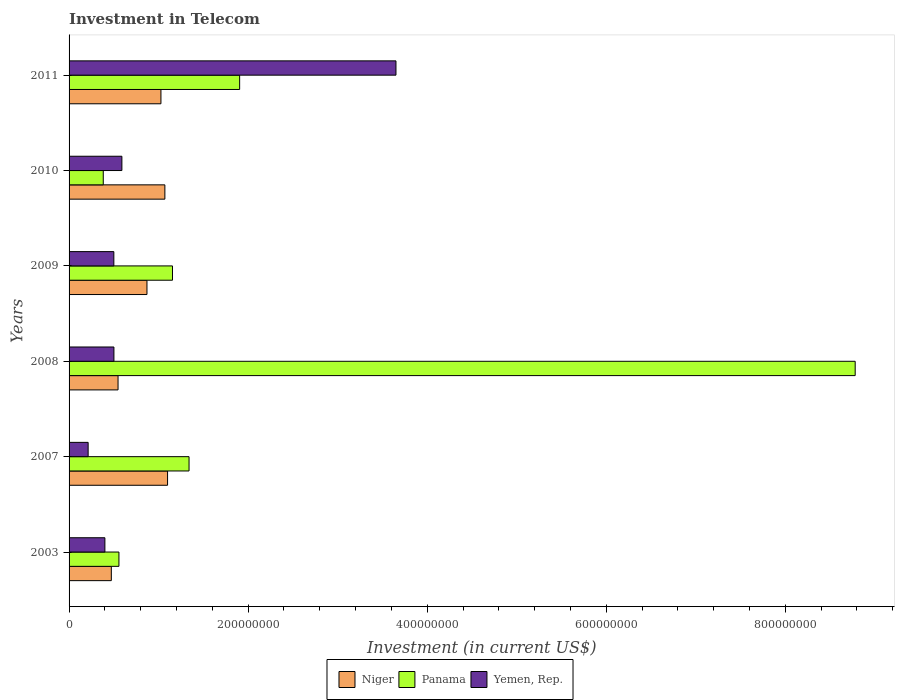How many groups of bars are there?
Provide a short and direct response. 6. How many bars are there on the 1st tick from the top?
Keep it short and to the point. 3. What is the label of the 6th group of bars from the top?
Keep it short and to the point. 2003. What is the amount invested in telecom in Panama in 2003?
Give a very brief answer. 5.57e+07. Across all years, what is the maximum amount invested in telecom in Yemen, Rep.?
Provide a succinct answer. 3.65e+08. Across all years, what is the minimum amount invested in telecom in Panama?
Give a very brief answer. 3.82e+07. In which year was the amount invested in telecom in Yemen, Rep. maximum?
Your answer should be very brief. 2011. In which year was the amount invested in telecom in Yemen, Rep. minimum?
Provide a short and direct response. 2007. What is the total amount invested in telecom in Yemen, Rep. in the graph?
Your response must be concise. 5.86e+08. What is the difference between the amount invested in telecom in Yemen, Rep. in 2009 and that in 2010?
Keep it short and to the point. -9.00e+06. What is the difference between the amount invested in telecom in Panama in 2010 and the amount invested in telecom in Niger in 2007?
Ensure brevity in your answer.  -7.18e+07. What is the average amount invested in telecom in Yemen, Rep. per year?
Ensure brevity in your answer.  9.76e+07. In the year 2003, what is the difference between the amount invested in telecom in Niger and amount invested in telecom in Panama?
Provide a succinct answer. -8.50e+06. Is the amount invested in telecom in Panama in 2007 less than that in 2010?
Offer a very short reply. No. What is the difference between the highest and the second highest amount invested in telecom in Niger?
Offer a terse response. 3.00e+06. What is the difference between the highest and the lowest amount invested in telecom in Niger?
Offer a terse response. 6.28e+07. In how many years, is the amount invested in telecom in Yemen, Rep. greater than the average amount invested in telecom in Yemen, Rep. taken over all years?
Offer a very short reply. 1. Is the sum of the amount invested in telecom in Niger in 2007 and 2010 greater than the maximum amount invested in telecom in Panama across all years?
Offer a very short reply. No. What does the 3rd bar from the top in 2007 represents?
Keep it short and to the point. Niger. What does the 1st bar from the bottom in 2007 represents?
Make the answer very short. Niger. Are all the bars in the graph horizontal?
Provide a succinct answer. Yes. How many years are there in the graph?
Provide a succinct answer. 6. What is the difference between two consecutive major ticks on the X-axis?
Provide a succinct answer. 2.00e+08. Are the values on the major ticks of X-axis written in scientific E-notation?
Provide a short and direct response. No. Does the graph contain grids?
Provide a succinct answer. No. How are the legend labels stacked?
Offer a terse response. Horizontal. What is the title of the graph?
Offer a very short reply. Investment in Telecom. Does "Libya" appear as one of the legend labels in the graph?
Keep it short and to the point. No. What is the label or title of the X-axis?
Your response must be concise. Investment (in current US$). What is the Investment (in current US$) of Niger in 2003?
Your answer should be very brief. 4.72e+07. What is the Investment (in current US$) of Panama in 2003?
Your answer should be compact. 5.57e+07. What is the Investment (in current US$) of Yemen, Rep. in 2003?
Keep it short and to the point. 4.00e+07. What is the Investment (in current US$) of Niger in 2007?
Your answer should be very brief. 1.10e+08. What is the Investment (in current US$) of Panama in 2007?
Ensure brevity in your answer.  1.34e+08. What is the Investment (in current US$) in Yemen, Rep. in 2007?
Your answer should be compact. 2.13e+07. What is the Investment (in current US$) in Niger in 2008?
Your answer should be very brief. 5.47e+07. What is the Investment (in current US$) of Panama in 2008?
Give a very brief answer. 8.78e+08. What is the Investment (in current US$) of Yemen, Rep. in 2008?
Your response must be concise. 5.01e+07. What is the Investment (in current US$) in Niger in 2009?
Make the answer very short. 8.70e+07. What is the Investment (in current US$) in Panama in 2009?
Your answer should be compact. 1.16e+08. What is the Investment (in current US$) of Yemen, Rep. in 2009?
Give a very brief answer. 5.00e+07. What is the Investment (in current US$) in Niger in 2010?
Ensure brevity in your answer.  1.07e+08. What is the Investment (in current US$) of Panama in 2010?
Offer a terse response. 3.82e+07. What is the Investment (in current US$) of Yemen, Rep. in 2010?
Your response must be concise. 5.90e+07. What is the Investment (in current US$) of Niger in 2011?
Ensure brevity in your answer.  1.03e+08. What is the Investment (in current US$) in Panama in 2011?
Provide a short and direct response. 1.90e+08. What is the Investment (in current US$) in Yemen, Rep. in 2011?
Keep it short and to the point. 3.65e+08. Across all years, what is the maximum Investment (in current US$) of Niger?
Make the answer very short. 1.10e+08. Across all years, what is the maximum Investment (in current US$) of Panama?
Provide a succinct answer. 8.78e+08. Across all years, what is the maximum Investment (in current US$) of Yemen, Rep.?
Provide a succinct answer. 3.65e+08. Across all years, what is the minimum Investment (in current US$) of Niger?
Keep it short and to the point. 4.72e+07. Across all years, what is the minimum Investment (in current US$) of Panama?
Your response must be concise. 3.82e+07. Across all years, what is the minimum Investment (in current US$) in Yemen, Rep.?
Offer a very short reply. 2.13e+07. What is the total Investment (in current US$) in Niger in the graph?
Make the answer very short. 5.08e+08. What is the total Investment (in current US$) of Panama in the graph?
Give a very brief answer. 1.41e+09. What is the total Investment (in current US$) in Yemen, Rep. in the graph?
Your answer should be very brief. 5.86e+08. What is the difference between the Investment (in current US$) in Niger in 2003 and that in 2007?
Keep it short and to the point. -6.28e+07. What is the difference between the Investment (in current US$) of Panama in 2003 and that in 2007?
Offer a very short reply. -7.83e+07. What is the difference between the Investment (in current US$) in Yemen, Rep. in 2003 and that in 2007?
Make the answer very short. 1.87e+07. What is the difference between the Investment (in current US$) in Niger in 2003 and that in 2008?
Provide a short and direct response. -7.50e+06. What is the difference between the Investment (in current US$) in Panama in 2003 and that in 2008?
Your answer should be compact. -8.22e+08. What is the difference between the Investment (in current US$) in Yemen, Rep. in 2003 and that in 2008?
Keep it short and to the point. -1.01e+07. What is the difference between the Investment (in current US$) in Niger in 2003 and that in 2009?
Offer a terse response. -3.98e+07. What is the difference between the Investment (in current US$) in Panama in 2003 and that in 2009?
Offer a very short reply. -5.98e+07. What is the difference between the Investment (in current US$) of Yemen, Rep. in 2003 and that in 2009?
Keep it short and to the point. -1.00e+07. What is the difference between the Investment (in current US$) of Niger in 2003 and that in 2010?
Your response must be concise. -5.98e+07. What is the difference between the Investment (in current US$) of Panama in 2003 and that in 2010?
Keep it short and to the point. 1.75e+07. What is the difference between the Investment (in current US$) of Yemen, Rep. in 2003 and that in 2010?
Your response must be concise. -1.90e+07. What is the difference between the Investment (in current US$) in Niger in 2003 and that in 2011?
Offer a very short reply. -5.54e+07. What is the difference between the Investment (in current US$) of Panama in 2003 and that in 2011?
Your response must be concise. -1.35e+08. What is the difference between the Investment (in current US$) in Yemen, Rep. in 2003 and that in 2011?
Your answer should be compact. -3.25e+08. What is the difference between the Investment (in current US$) in Niger in 2007 and that in 2008?
Give a very brief answer. 5.53e+07. What is the difference between the Investment (in current US$) of Panama in 2007 and that in 2008?
Offer a terse response. -7.44e+08. What is the difference between the Investment (in current US$) in Yemen, Rep. in 2007 and that in 2008?
Keep it short and to the point. -2.88e+07. What is the difference between the Investment (in current US$) of Niger in 2007 and that in 2009?
Make the answer very short. 2.30e+07. What is the difference between the Investment (in current US$) in Panama in 2007 and that in 2009?
Make the answer very short. 1.85e+07. What is the difference between the Investment (in current US$) in Yemen, Rep. in 2007 and that in 2009?
Keep it short and to the point. -2.87e+07. What is the difference between the Investment (in current US$) of Panama in 2007 and that in 2010?
Keep it short and to the point. 9.58e+07. What is the difference between the Investment (in current US$) of Yemen, Rep. in 2007 and that in 2010?
Provide a short and direct response. -3.77e+07. What is the difference between the Investment (in current US$) of Niger in 2007 and that in 2011?
Your answer should be very brief. 7.40e+06. What is the difference between the Investment (in current US$) of Panama in 2007 and that in 2011?
Ensure brevity in your answer.  -5.65e+07. What is the difference between the Investment (in current US$) of Yemen, Rep. in 2007 and that in 2011?
Provide a short and direct response. -3.44e+08. What is the difference between the Investment (in current US$) in Niger in 2008 and that in 2009?
Make the answer very short. -3.23e+07. What is the difference between the Investment (in current US$) in Panama in 2008 and that in 2009?
Offer a very short reply. 7.62e+08. What is the difference between the Investment (in current US$) of Niger in 2008 and that in 2010?
Your answer should be very brief. -5.23e+07. What is the difference between the Investment (in current US$) in Panama in 2008 and that in 2010?
Give a very brief answer. 8.40e+08. What is the difference between the Investment (in current US$) of Yemen, Rep. in 2008 and that in 2010?
Your response must be concise. -8.90e+06. What is the difference between the Investment (in current US$) in Niger in 2008 and that in 2011?
Ensure brevity in your answer.  -4.79e+07. What is the difference between the Investment (in current US$) in Panama in 2008 and that in 2011?
Keep it short and to the point. 6.88e+08. What is the difference between the Investment (in current US$) of Yemen, Rep. in 2008 and that in 2011?
Your answer should be very brief. -3.15e+08. What is the difference between the Investment (in current US$) in Niger in 2009 and that in 2010?
Offer a terse response. -2.00e+07. What is the difference between the Investment (in current US$) of Panama in 2009 and that in 2010?
Offer a terse response. 7.73e+07. What is the difference between the Investment (in current US$) in Yemen, Rep. in 2009 and that in 2010?
Offer a terse response. -9.00e+06. What is the difference between the Investment (in current US$) in Niger in 2009 and that in 2011?
Ensure brevity in your answer.  -1.56e+07. What is the difference between the Investment (in current US$) of Panama in 2009 and that in 2011?
Make the answer very short. -7.50e+07. What is the difference between the Investment (in current US$) in Yemen, Rep. in 2009 and that in 2011?
Give a very brief answer. -3.15e+08. What is the difference between the Investment (in current US$) of Niger in 2010 and that in 2011?
Offer a very short reply. 4.40e+06. What is the difference between the Investment (in current US$) of Panama in 2010 and that in 2011?
Provide a short and direct response. -1.52e+08. What is the difference between the Investment (in current US$) in Yemen, Rep. in 2010 and that in 2011?
Offer a terse response. -3.06e+08. What is the difference between the Investment (in current US$) in Niger in 2003 and the Investment (in current US$) in Panama in 2007?
Provide a succinct answer. -8.68e+07. What is the difference between the Investment (in current US$) of Niger in 2003 and the Investment (in current US$) of Yemen, Rep. in 2007?
Provide a short and direct response. 2.59e+07. What is the difference between the Investment (in current US$) in Panama in 2003 and the Investment (in current US$) in Yemen, Rep. in 2007?
Ensure brevity in your answer.  3.44e+07. What is the difference between the Investment (in current US$) in Niger in 2003 and the Investment (in current US$) in Panama in 2008?
Keep it short and to the point. -8.31e+08. What is the difference between the Investment (in current US$) of Niger in 2003 and the Investment (in current US$) of Yemen, Rep. in 2008?
Make the answer very short. -2.90e+06. What is the difference between the Investment (in current US$) of Panama in 2003 and the Investment (in current US$) of Yemen, Rep. in 2008?
Offer a terse response. 5.60e+06. What is the difference between the Investment (in current US$) of Niger in 2003 and the Investment (in current US$) of Panama in 2009?
Provide a succinct answer. -6.83e+07. What is the difference between the Investment (in current US$) in Niger in 2003 and the Investment (in current US$) in Yemen, Rep. in 2009?
Offer a very short reply. -2.80e+06. What is the difference between the Investment (in current US$) of Panama in 2003 and the Investment (in current US$) of Yemen, Rep. in 2009?
Keep it short and to the point. 5.70e+06. What is the difference between the Investment (in current US$) in Niger in 2003 and the Investment (in current US$) in Panama in 2010?
Your answer should be very brief. 9.00e+06. What is the difference between the Investment (in current US$) of Niger in 2003 and the Investment (in current US$) of Yemen, Rep. in 2010?
Provide a succinct answer. -1.18e+07. What is the difference between the Investment (in current US$) of Panama in 2003 and the Investment (in current US$) of Yemen, Rep. in 2010?
Provide a short and direct response. -3.30e+06. What is the difference between the Investment (in current US$) of Niger in 2003 and the Investment (in current US$) of Panama in 2011?
Offer a very short reply. -1.43e+08. What is the difference between the Investment (in current US$) in Niger in 2003 and the Investment (in current US$) in Yemen, Rep. in 2011?
Offer a very short reply. -3.18e+08. What is the difference between the Investment (in current US$) of Panama in 2003 and the Investment (in current US$) of Yemen, Rep. in 2011?
Offer a very short reply. -3.09e+08. What is the difference between the Investment (in current US$) of Niger in 2007 and the Investment (in current US$) of Panama in 2008?
Provide a succinct answer. -7.68e+08. What is the difference between the Investment (in current US$) in Niger in 2007 and the Investment (in current US$) in Yemen, Rep. in 2008?
Offer a terse response. 5.99e+07. What is the difference between the Investment (in current US$) of Panama in 2007 and the Investment (in current US$) of Yemen, Rep. in 2008?
Provide a succinct answer. 8.39e+07. What is the difference between the Investment (in current US$) of Niger in 2007 and the Investment (in current US$) of Panama in 2009?
Give a very brief answer. -5.50e+06. What is the difference between the Investment (in current US$) of Niger in 2007 and the Investment (in current US$) of Yemen, Rep. in 2009?
Make the answer very short. 6.00e+07. What is the difference between the Investment (in current US$) in Panama in 2007 and the Investment (in current US$) in Yemen, Rep. in 2009?
Your answer should be compact. 8.40e+07. What is the difference between the Investment (in current US$) of Niger in 2007 and the Investment (in current US$) of Panama in 2010?
Give a very brief answer. 7.18e+07. What is the difference between the Investment (in current US$) of Niger in 2007 and the Investment (in current US$) of Yemen, Rep. in 2010?
Your answer should be compact. 5.10e+07. What is the difference between the Investment (in current US$) of Panama in 2007 and the Investment (in current US$) of Yemen, Rep. in 2010?
Ensure brevity in your answer.  7.50e+07. What is the difference between the Investment (in current US$) in Niger in 2007 and the Investment (in current US$) in Panama in 2011?
Ensure brevity in your answer.  -8.05e+07. What is the difference between the Investment (in current US$) in Niger in 2007 and the Investment (in current US$) in Yemen, Rep. in 2011?
Your response must be concise. -2.55e+08. What is the difference between the Investment (in current US$) in Panama in 2007 and the Investment (in current US$) in Yemen, Rep. in 2011?
Your answer should be compact. -2.31e+08. What is the difference between the Investment (in current US$) of Niger in 2008 and the Investment (in current US$) of Panama in 2009?
Your answer should be very brief. -6.08e+07. What is the difference between the Investment (in current US$) of Niger in 2008 and the Investment (in current US$) of Yemen, Rep. in 2009?
Offer a very short reply. 4.70e+06. What is the difference between the Investment (in current US$) in Panama in 2008 and the Investment (in current US$) in Yemen, Rep. in 2009?
Your response must be concise. 8.28e+08. What is the difference between the Investment (in current US$) of Niger in 2008 and the Investment (in current US$) of Panama in 2010?
Your answer should be compact. 1.65e+07. What is the difference between the Investment (in current US$) of Niger in 2008 and the Investment (in current US$) of Yemen, Rep. in 2010?
Provide a short and direct response. -4.30e+06. What is the difference between the Investment (in current US$) of Panama in 2008 and the Investment (in current US$) of Yemen, Rep. in 2010?
Offer a very short reply. 8.19e+08. What is the difference between the Investment (in current US$) of Niger in 2008 and the Investment (in current US$) of Panama in 2011?
Provide a succinct answer. -1.36e+08. What is the difference between the Investment (in current US$) in Niger in 2008 and the Investment (in current US$) in Yemen, Rep. in 2011?
Your answer should be compact. -3.10e+08. What is the difference between the Investment (in current US$) in Panama in 2008 and the Investment (in current US$) in Yemen, Rep. in 2011?
Offer a very short reply. 5.13e+08. What is the difference between the Investment (in current US$) of Niger in 2009 and the Investment (in current US$) of Panama in 2010?
Your answer should be very brief. 4.88e+07. What is the difference between the Investment (in current US$) in Niger in 2009 and the Investment (in current US$) in Yemen, Rep. in 2010?
Your response must be concise. 2.80e+07. What is the difference between the Investment (in current US$) in Panama in 2009 and the Investment (in current US$) in Yemen, Rep. in 2010?
Provide a short and direct response. 5.65e+07. What is the difference between the Investment (in current US$) of Niger in 2009 and the Investment (in current US$) of Panama in 2011?
Ensure brevity in your answer.  -1.04e+08. What is the difference between the Investment (in current US$) in Niger in 2009 and the Investment (in current US$) in Yemen, Rep. in 2011?
Offer a terse response. -2.78e+08. What is the difference between the Investment (in current US$) in Panama in 2009 and the Investment (in current US$) in Yemen, Rep. in 2011?
Offer a very short reply. -2.50e+08. What is the difference between the Investment (in current US$) in Niger in 2010 and the Investment (in current US$) in Panama in 2011?
Your answer should be very brief. -8.35e+07. What is the difference between the Investment (in current US$) of Niger in 2010 and the Investment (in current US$) of Yemen, Rep. in 2011?
Your response must be concise. -2.58e+08. What is the difference between the Investment (in current US$) of Panama in 2010 and the Investment (in current US$) of Yemen, Rep. in 2011?
Your response must be concise. -3.27e+08. What is the average Investment (in current US$) in Niger per year?
Your answer should be compact. 8.48e+07. What is the average Investment (in current US$) in Panama per year?
Make the answer very short. 2.35e+08. What is the average Investment (in current US$) in Yemen, Rep. per year?
Provide a short and direct response. 9.76e+07. In the year 2003, what is the difference between the Investment (in current US$) in Niger and Investment (in current US$) in Panama?
Provide a succinct answer. -8.50e+06. In the year 2003, what is the difference between the Investment (in current US$) in Niger and Investment (in current US$) in Yemen, Rep.?
Ensure brevity in your answer.  7.20e+06. In the year 2003, what is the difference between the Investment (in current US$) of Panama and Investment (in current US$) of Yemen, Rep.?
Your answer should be very brief. 1.57e+07. In the year 2007, what is the difference between the Investment (in current US$) in Niger and Investment (in current US$) in Panama?
Your answer should be compact. -2.40e+07. In the year 2007, what is the difference between the Investment (in current US$) of Niger and Investment (in current US$) of Yemen, Rep.?
Ensure brevity in your answer.  8.87e+07. In the year 2007, what is the difference between the Investment (in current US$) in Panama and Investment (in current US$) in Yemen, Rep.?
Provide a succinct answer. 1.13e+08. In the year 2008, what is the difference between the Investment (in current US$) in Niger and Investment (in current US$) in Panama?
Keep it short and to the point. -8.23e+08. In the year 2008, what is the difference between the Investment (in current US$) of Niger and Investment (in current US$) of Yemen, Rep.?
Your answer should be very brief. 4.60e+06. In the year 2008, what is the difference between the Investment (in current US$) of Panama and Investment (in current US$) of Yemen, Rep.?
Your answer should be compact. 8.28e+08. In the year 2009, what is the difference between the Investment (in current US$) in Niger and Investment (in current US$) in Panama?
Ensure brevity in your answer.  -2.85e+07. In the year 2009, what is the difference between the Investment (in current US$) of Niger and Investment (in current US$) of Yemen, Rep.?
Ensure brevity in your answer.  3.70e+07. In the year 2009, what is the difference between the Investment (in current US$) of Panama and Investment (in current US$) of Yemen, Rep.?
Ensure brevity in your answer.  6.55e+07. In the year 2010, what is the difference between the Investment (in current US$) in Niger and Investment (in current US$) in Panama?
Your answer should be compact. 6.88e+07. In the year 2010, what is the difference between the Investment (in current US$) of Niger and Investment (in current US$) of Yemen, Rep.?
Give a very brief answer. 4.80e+07. In the year 2010, what is the difference between the Investment (in current US$) in Panama and Investment (in current US$) in Yemen, Rep.?
Offer a terse response. -2.08e+07. In the year 2011, what is the difference between the Investment (in current US$) in Niger and Investment (in current US$) in Panama?
Make the answer very short. -8.79e+07. In the year 2011, what is the difference between the Investment (in current US$) in Niger and Investment (in current US$) in Yemen, Rep.?
Provide a succinct answer. -2.62e+08. In the year 2011, what is the difference between the Investment (in current US$) of Panama and Investment (in current US$) of Yemen, Rep.?
Your answer should be compact. -1.75e+08. What is the ratio of the Investment (in current US$) in Niger in 2003 to that in 2007?
Ensure brevity in your answer.  0.43. What is the ratio of the Investment (in current US$) of Panama in 2003 to that in 2007?
Provide a short and direct response. 0.42. What is the ratio of the Investment (in current US$) of Yemen, Rep. in 2003 to that in 2007?
Keep it short and to the point. 1.88. What is the ratio of the Investment (in current US$) in Niger in 2003 to that in 2008?
Your answer should be compact. 0.86. What is the ratio of the Investment (in current US$) in Panama in 2003 to that in 2008?
Your answer should be very brief. 0.06. What is the ratio of the Investment (in current US$) of Yemen, Rep. in 2003 to that in 2008?
Give a very brief answer. 0.8. What is the ratio of the Investment (in current US$) of Niger in 2003 to that in 2009?
Give a very brief answer. 0.54. What is the ratio of the Investment (in current US$) of Panama in 2003 to that in 2009?
Give a very brief answer. 0.48. What is the ratio of the Investment (in current US$) in Yemen, Rep. in 2003 to that in 2009?
Your answer should be compact. 0.8. What is the ratio of the Investment (in current US$) of Niger in 2003 to that in 2010?
Your answer should be compact. 0.44. What is the ratio of the Investment (in current US$) in Panama in 2003 to that in 2010?
Your answer should be compact. 1.46. What is the ratio of the Investment (in current US$) in Yemen, Rep. in 2003 to that in 2010?
Make the answer very short. 0.68. What is the ratio of the Investment (in current US$) in Niger in 2003 to that in 2011?
Your response must be concise. 0.46. What is the ratio of the Investment (in current US$) of Panama in 2003 to that in 2011?
Ensure brevity in your answer.  0.29. What is the ratio of the Investment (in current US$) of Yemen, Rep. in 2003 to that in 2011?
Give a very brief answer. 0.11. What is the ratio of the Investment (in current US$) of Niger in 2007 to that in 2008?
Provide a short and direct response. 2.01. What is the ratio of the Investment (in current US$) of Panama in 2007 to that in 2008?
Keep it short and to the point. 0.15. What is the ratio of the Investment (in current US$) of Yemen, Rep. in 2007 to that in 2008?
Make the answer very short. 0.43. What is the ratio of the Investment (in current US$) of Niger in 2007 to that in 2009?
Ensure brevity in your answer.  1.26. What is the ratio of the Investment (in current US$) in Panama in 2007 to that in 2009?
Give a very brief answer. 1.16. What is the ratio of the Investment (in current US$) of Yemen, Rep. in 2007 to that in 2009?
Offer a very short reply. 0.43. What is the ratio of the Investment (in current US$) of Niger in 2007 to that in 2010?
Your response must be concise. 1.03. What is the ratio of the Investment (in current US$) of Panama in 2007 to that in 2010?
Ensure brevity in your answer.  3.51. What is the ratio of the Investment (in current US$) in Yemen, Rep. in 2007 to that in 2010?
Offer a terse response. 0.36. What is the ratio of the Investment (in current US$) of Niger in 2007 to that in 2011?
Keep it short and to the point. 1.07. What is the ratio of the Investment (in current US$) of Panama in 2007 to that in 2011?
Provide a succinct answer. 0.7. What is the ratio of the Investment (in current US$) of Yemen, Rep. in 2007 to that in 2011?
Make the answer very short. 0.06. What is the ratio of the Investment (in current US$) of Niger in 2008 to that in 2009?
Offer a terse response. 0.63. What is the ratio of the Investment (in current US$) in Panama in 2008 to that in 2009?
Keep it short and to the point. 7.6. What is the ratio of the Investment (in current US$) in Niger in 2008 to that in 2010?
Your answer should be compact. 0.51. What is the ratio of the Investment (in current US$) of Panama in 2008 to that in 2010?
Offer a very short reply. 22.98. What is the ratio of the Investment (in current US$) in Yemen, Rep. in 2008 to that in 2010?
Provide a short and direct response. 0.85. What is the ratio of the Investment (in current US$) in Niger in 2008 to that in 2011?
Ensure brevity in your answer.  0.53. What is the ratio of the Investment (in current US$) in Panama in 2008 to that in 2011?
Your answer should be compact. 4.61. What is the ratio of the Investment (in current US$) of Yemen, Rep. in 2008 to that in 2011?
Keep it short and to the point. 0.14. What is the ratio of the Investment (in current US$) of Niger in 2009 to that in 2010?
Provide a short and direct response. 0.81. What is the ratio of the Investment (in current US$) of Panama in 2009 to that in 2010?
Provide a succinct answer. 3.02. What is the ratio of the Investment (in current US$) of Yemen, Rep. in 2009 to that in 2010?
Make the answer very short. 0.85. What is the ratio of the Investment (in current US$) in Niger in 2009 to that in 2011?
Your response must be concise. 0.85. What is the ratio of the Investment (in current US$) in Panama in 2009 to that in 2011?
Offer a terse response. 0.61. What is the ratio of the Investment (in current US$) of Yemen, Rep. in 2009 to that in 2011?
Provide a succinct answer. 0.14. What is the ratio of the Investment (in current US$) of Niger in 2010 to that in 2011?
Offer a terse response. 1.04. What is the ratio of the Investment (in current US$) of Panama in 2010 to that in 2011?
Give a very brief answer. 0.2. What is the ratio of the Investment (in current US$) of Yemen, Rep. in 2010 to that in 2011?
Offer a terse response. 0.16. What is the difference between the highest and the second highest Investment (in current US$) in Niger?
Your answer should be very brief. 3.00e+06. What is the difference between the highest and the second highest Investment (in current US$) in Panama?
Your answer should be compact. 6.88e+08. What is the difference between the highest and the second highest Investment (in current US$) in Yemen, Rep.?
Your answer should be very brief. 3.06e+08. What is the difference between the highest and the lowest Investment (in current US$) of Niger?
Your response must be concise. 6.28e+07. What is the difference between the highest and the lowest Investment (in current US$) in Panama?
Make the answer very short. 8.40e+08. What is the difference between the highest and the lowest Investment (in current US$) of Yemen, Rep.?
Provide a short and direct response. 3.44e+08. 